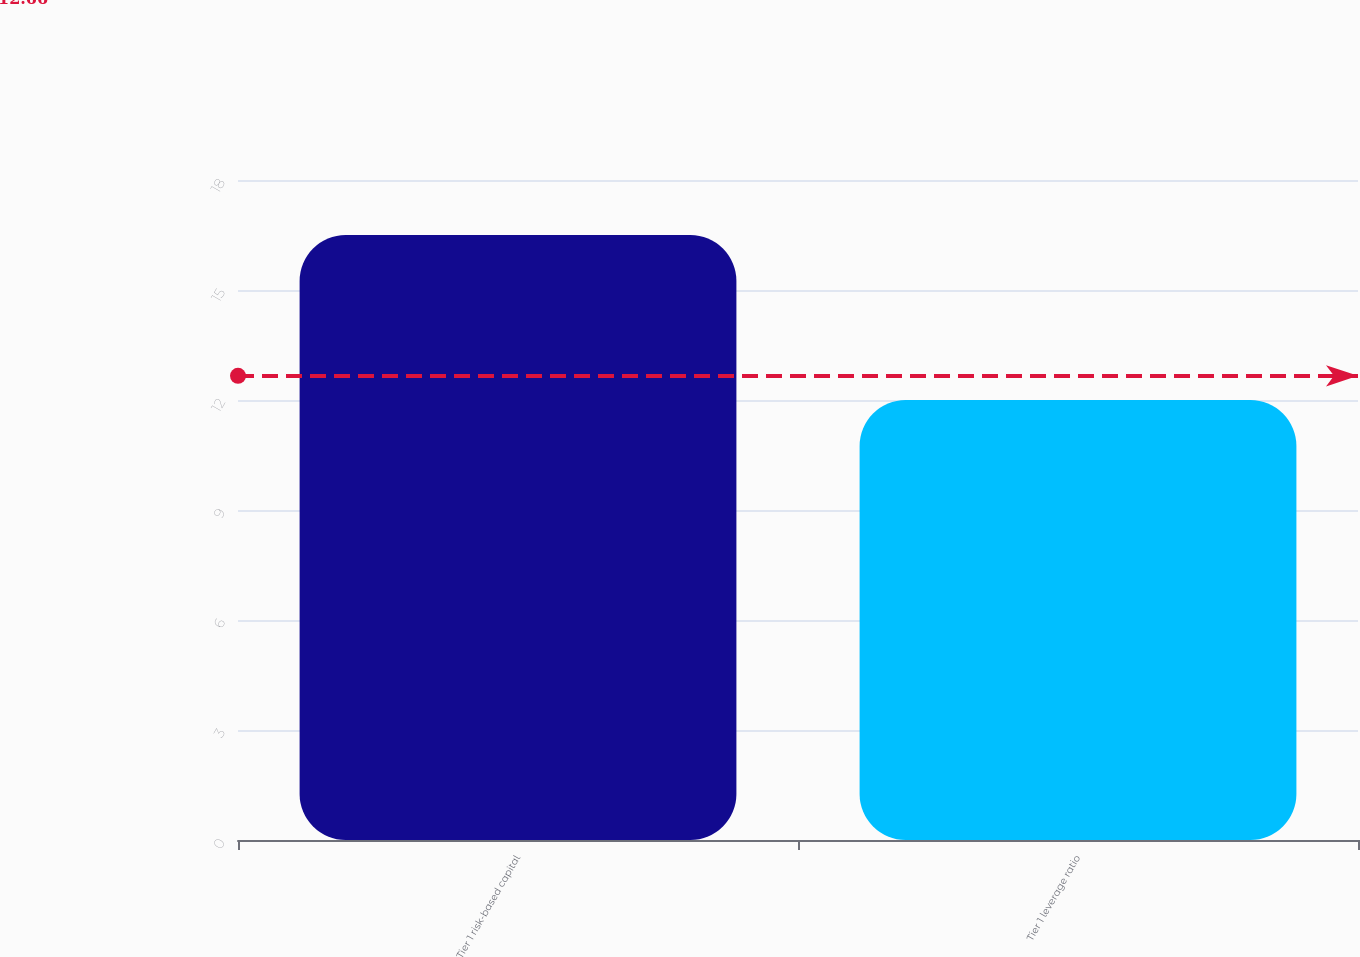<chart> <loc_0><loc_0><loc_500><loc_500><bar_chart><fcel>Tier 1 risk-based capital<fcel>Tier 1 leverage ratio<nl><fcel>16.5<fcel>12<nl></chart> 